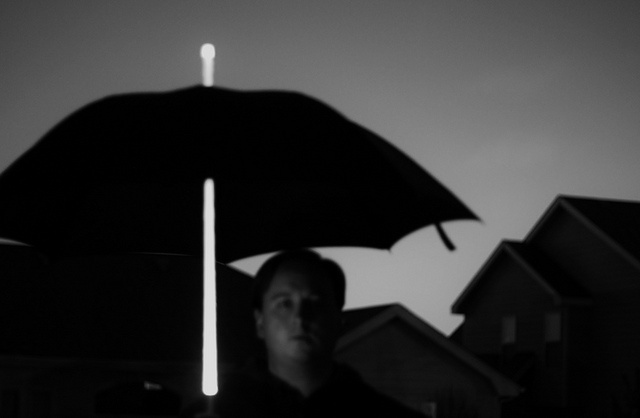Describe the objects in this image and their specific colors. I can see umbrella in black, lightgray, gray, and darkgray tones and people in black and gray tones in this image. 